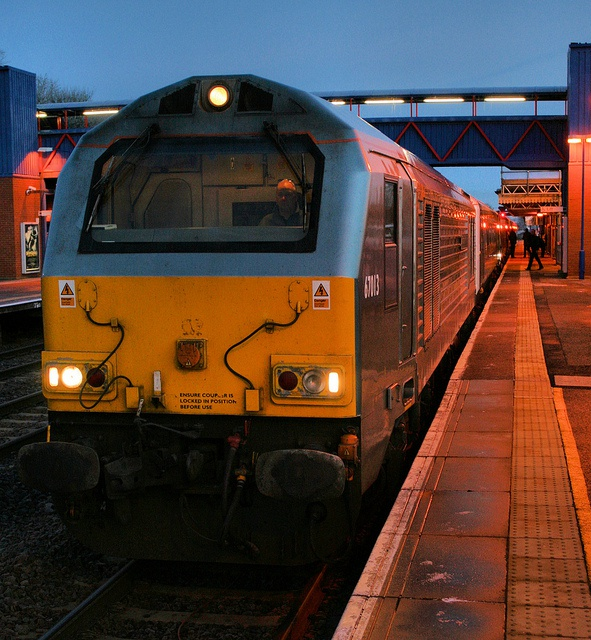Describe the objects in this image and their specific colors. I can see train in gray, black, red, maroon, and blue tones, people in gray, black, maroon, red, and brown tones, people in gray, black, maroon, and purple tones, people in gray, black, maroon, and brown tones, and people in gray, black, maroon, and red tones in this image. 